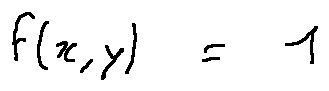<formula> <loc_0><loc_0><loc_500><loc_500>f ( x , y ) = 1</formula> 